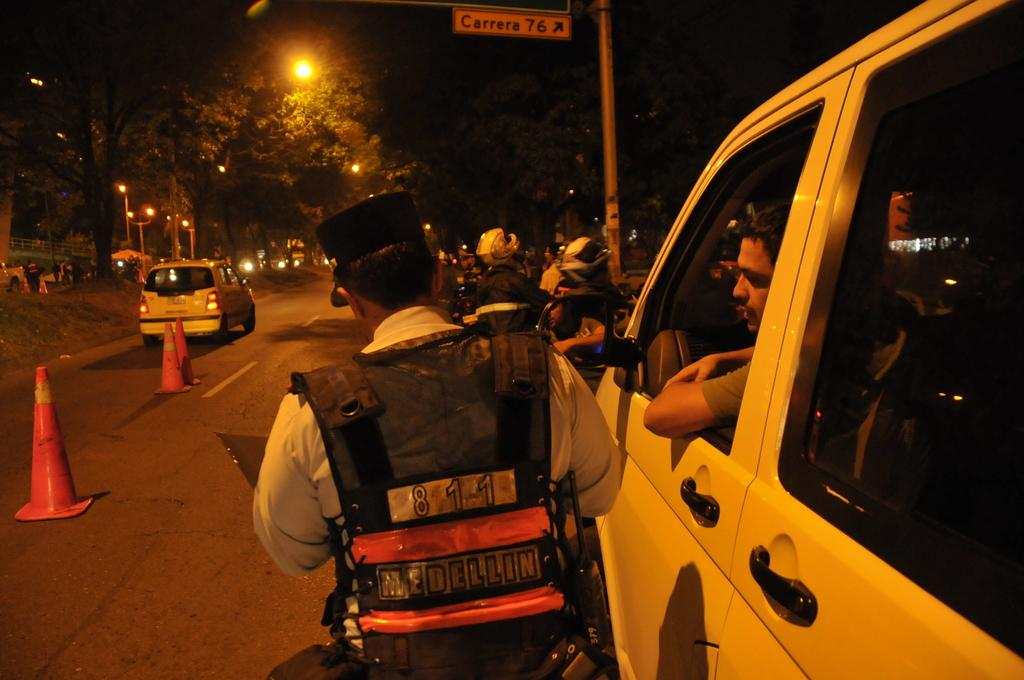<image>
Summarize the visual content of the image. a police officer stoping a man in a van at Carrera 76 